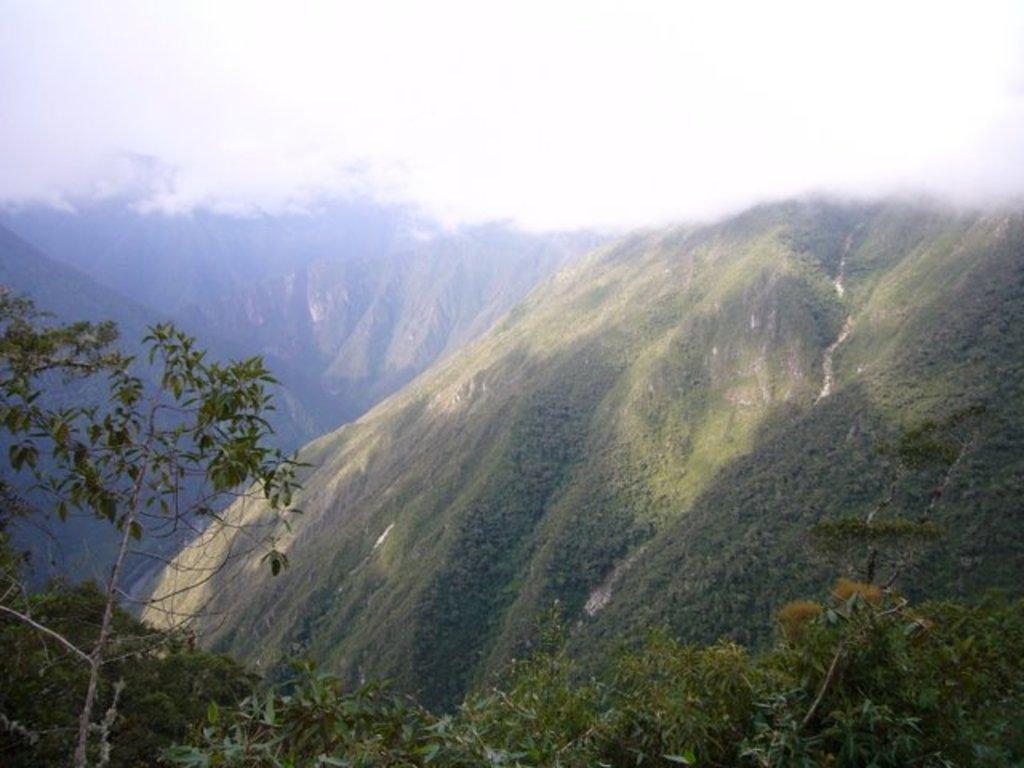How would you summarize this image in a sentence or two? In the foreground of the image we can see a group of trees. In the background, we can see mountains and the sky. 